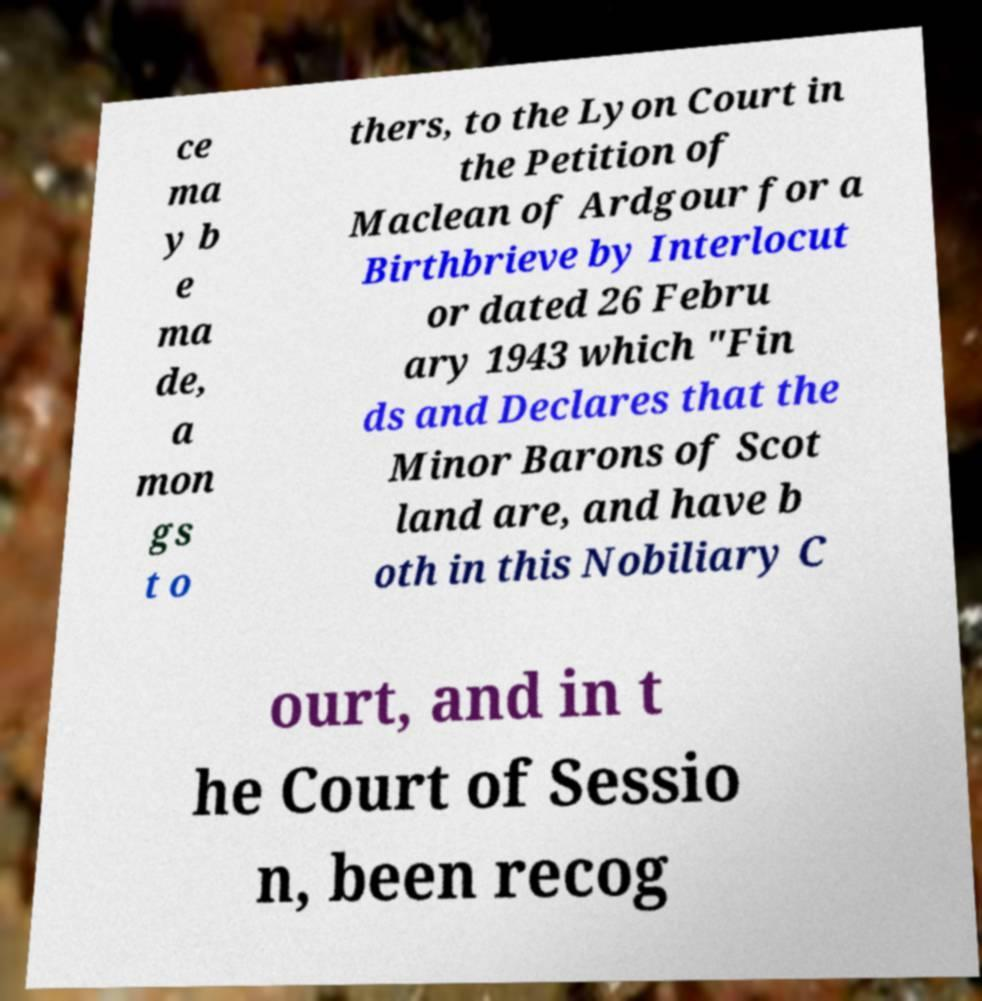What messages or text are displayed in this image? I need them in a readable, typed format. ce ma y b e ma de, a mon gs t o thers, to the Lyon Court in the Petition of Maclean of Ardgour for a Birthbrieve by Interlocut or dated 26 Febru ary 1943 which "Fin ds and Declares that the Minor Barons of Scot land are, and have b oth in this Nobiliary C ourt, and in t he Court of Sessio n, been recog 